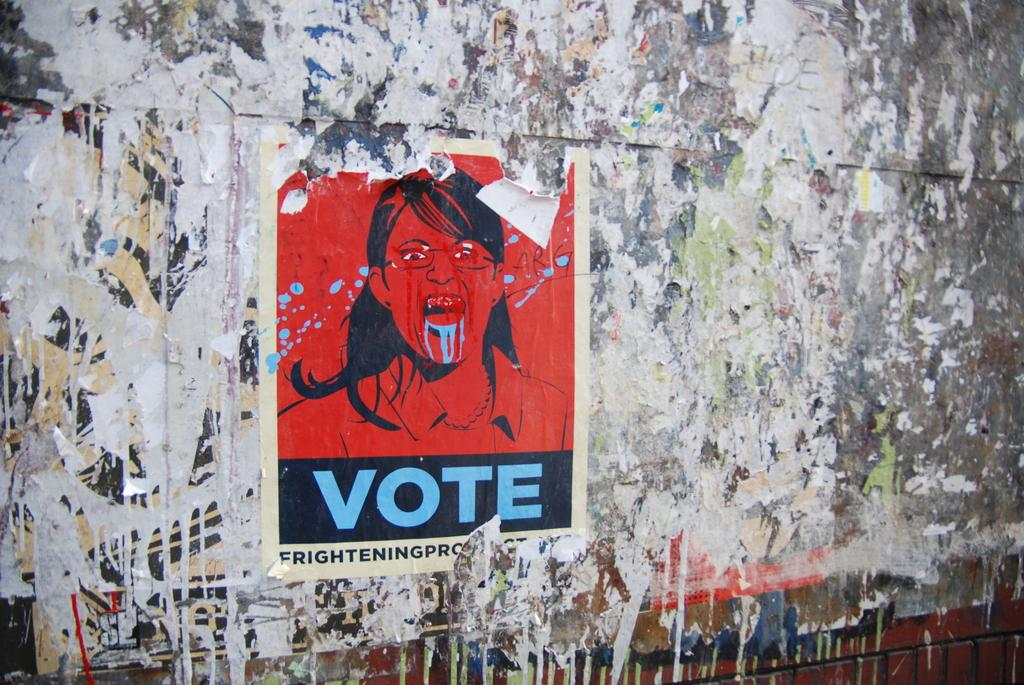What is on the wall in the image? There is a poster on the wall in the image. What is depicted on the poster? The poster contains a sketch. Are there any words on the poster? Yes, the poster contains text. How many legs are visible in the sketch on the poster? There is no information about legs or any specific subject in the sketch on the poster, so it cannot be determined from the image. 